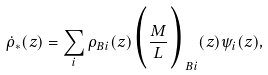Convert formula to latex. <formula><loc_0><loc_0><loc_500><loc_500>\dot { \rho } _ { * } ( z ) = \sum _ { i } { \rho } _ { B i } ( z ) \Big { ( } { \frac { M } { L } } \Big { ) } _ { B i } ( z ) { \psi } _ { i } ( z ) ,</formula> 